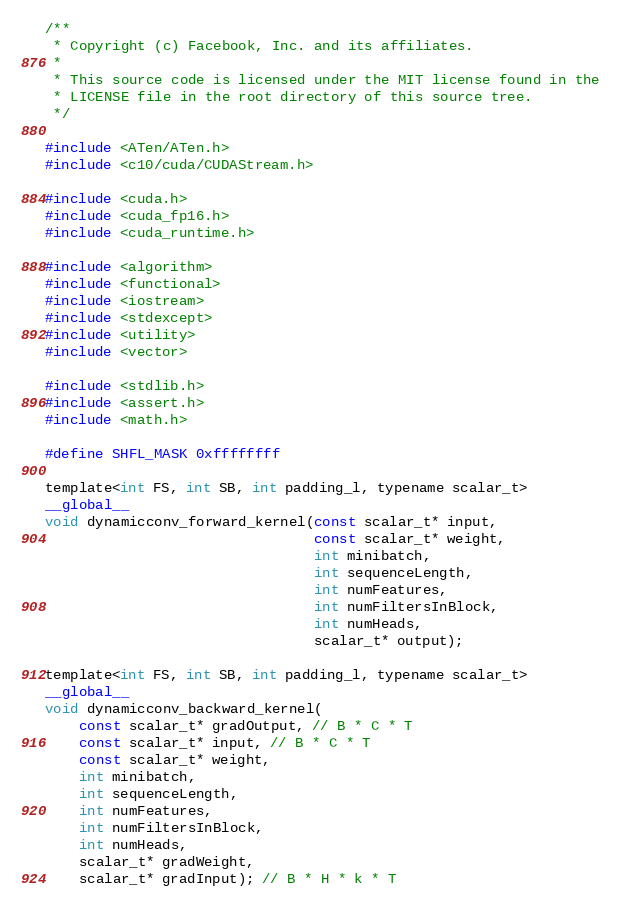<code> <loc_0><loc_0><loc_500><loc_500><_Cuda_>/**
 * Copyright (c) Facebook, Inc. and its affiliates.
 * 
 * This source code is licensed under the MIT license found in the
 * LICENSE file in the root directory of this source tree.
 */

#include <ATen/ATen.h>
#include <c10/cuda/CUDAStream.h>

#include <cuda.h>
#include <cuda_fp16.h>
#include <cuda_runtime.h>

#include <algorithm>
#include <functional>
#include <iostream>
#include <stdexcept>
#include <utility>
#include <vector>

#include <stdlib.h>
#include <assert.h>
#include <math.h>

#define SHFL_MASK 0xffffffff

template<int FS, int SB, int padding_l, typename scalar_t>
__global__
void dynamicconv_forward_kernel(const scalar_t* input,
                                const scalar_t* weight,
                                int minibatch, 
                                int sequenceLength,
                                int numFeatures, 
                                int numFiltersInBlock,
                                int numHeads,
                                scalar_t* output);

template<int FS, int SB, int padding_l, typename scalar_t>
__global__
void dynamicconv_backward_kernel(
    const scalar_t* gradOutput, // B * C * T
    const scalar_t* input, // B * C * T
    const scalar_t* weight,
    int minibatch,
    int sequenceLength,
    int numFeatures,
    int numFiltersInBlock,
    int numHeads,
    scalar_t* gradWeight,
    scalar_t* gradInput); // B * H * k * T
</code> 